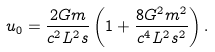<formula> <loc_0><loc_0><loc_500><loc_500>u _ { 0 } = \frac { 2 G m } { c ^ { 2 } L ^ { 2 } s } \left ( 1 + \frac { 8 G ^ { 2 } m ^ { 2 } } { c ^ { 4 } L ^ { 2 } s ^ { 2 } } \right ) .</formula> 